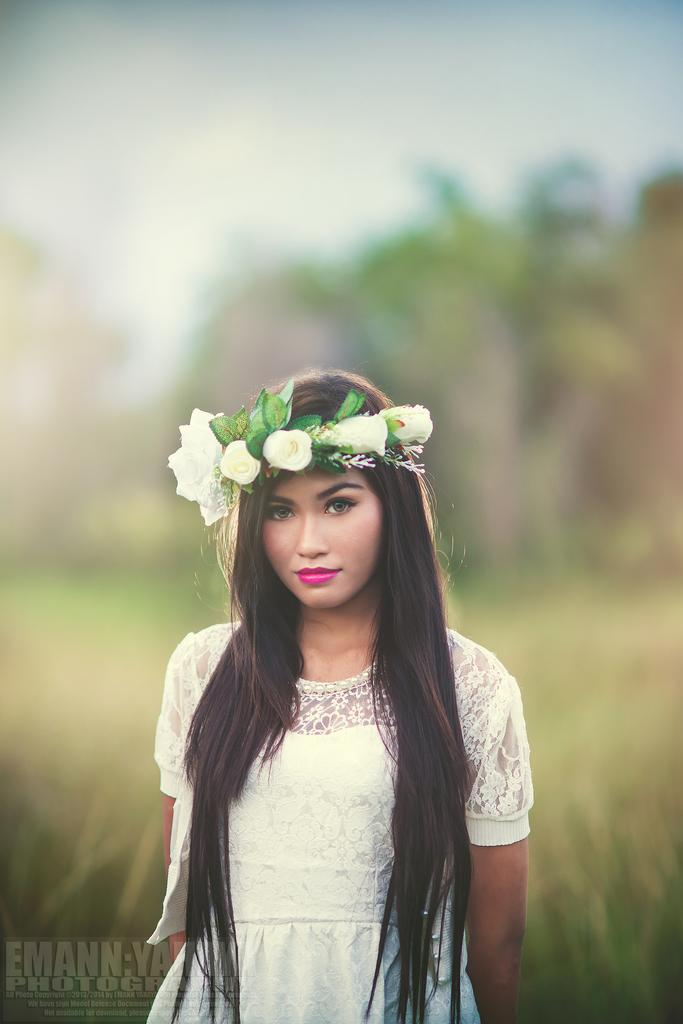Who is the main subject in the image? There is a woman in the image. What is the woman wearing on her head? The woman is wearing a tiara. Can you describe the background of the image? The background of the image is blurred. What type of rhythm can be heard coming from the banana in the image? There is no banana present in the image, and therefore no rhythm can be heard. 